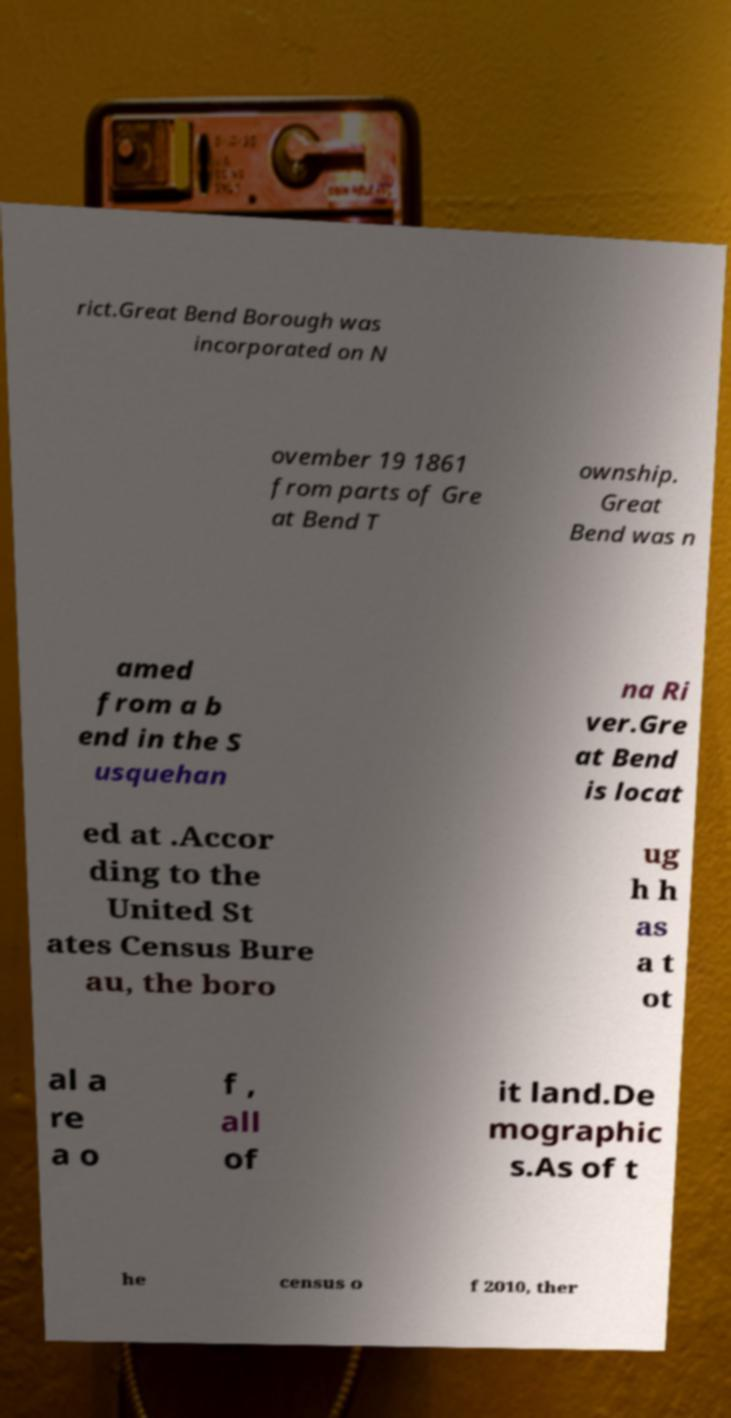What messages or text are displayed in this image? I need them in a readable, typed format. rict.Great Bend Borough was incorporated on N ovember 19 1861 from parts of Gre at Bend T ownship. Great Bend was n amed from a b end in the S usquehan na Ri ver.Gre at Bend is locat ed at .Accor ding to the United St ates Census Bure au, the boro ug h h as a t ot al a re a o f , all of it land.De mographic s.As of t he census o f 2010, ther 